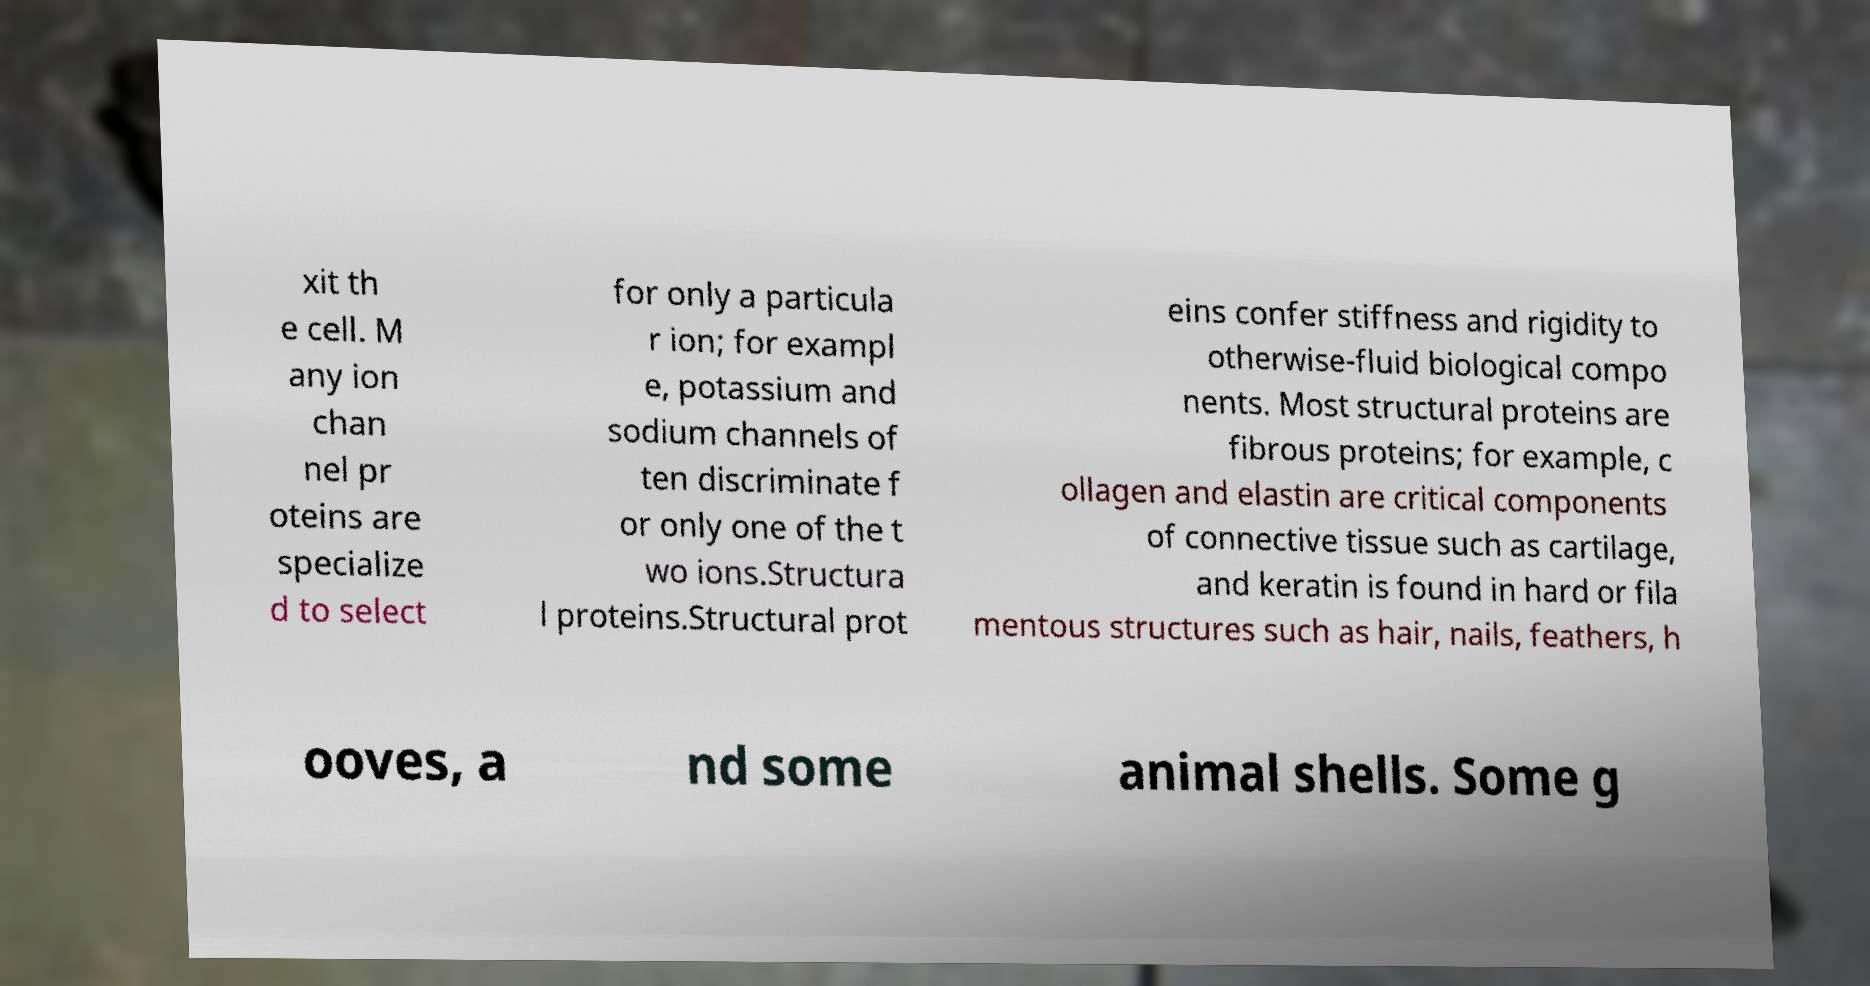I need the written content from this picture converted into text. Can you do that? xit th e cell. M any ion chan nel pr oteins are specialize d to select for only a particula r ion; for exampl e, potassium and sodium channels of ten discriminate f or only one of the t wo ions.Structura l proteins.Structural prot eins confer stiffness and rigidity to otherwise-fluid biological compo nents. Most structural proteins are fibrous proteins; for example, c ollagen and elastin are critical components of connective tissue such as cartilage, and keratin is found in hard or fila mentous structures such as hair, nails, feathers, h ooves, a nd some animal shells. Some g 